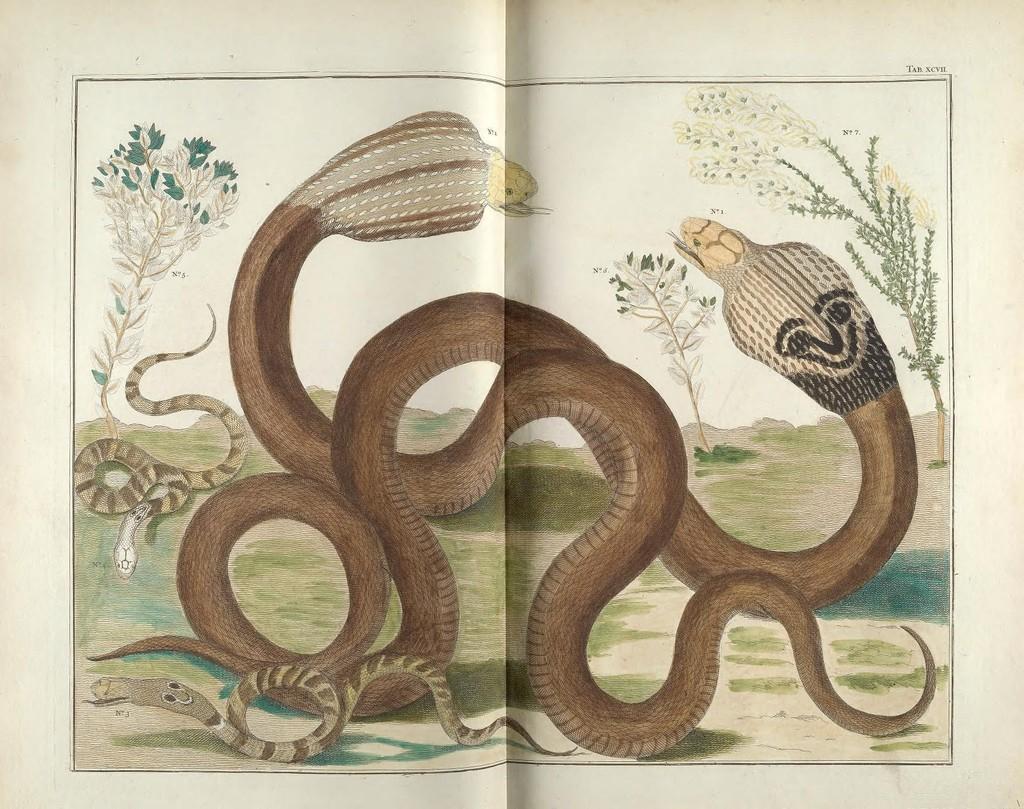Please provide a concise description of this image. In this picture we can see a painting of two snakes mainly and this two snakes are on a land with grass, trees and besides this two big snakes we have small snakes surrounding it. 